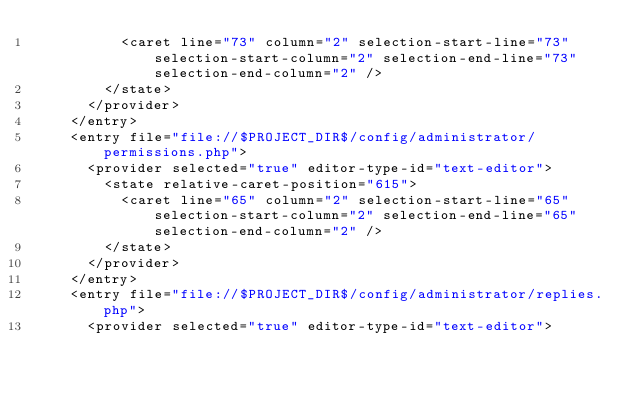Convert code to text. <code><loc_0><loc_0><loc_500><loc_500><_XML_>          <caret line="73" column="2" selection-start-line="73" selection-start-column="2" selection-end-line="73" selection-end-column="2" />
        </state>
      </provider>
    </entry>
    <entry file="file://$PROJECT_DIR$/config/administrator/permissions.php">
      <provider selected="true" editor-type-id="text-editor">
        <state relative-caret-position="615">
          <caret line="65" column="2" selection-start-line="65" selection-start-column="2" selection-end-line="65" selection-end-column="2" />
        </state>
      </provider>
    </entry>
    <entry file="file://$PROJECT_DIR$/config/administrator/replies.php">
      <provider selected="true" editor-type-id="text-editor"></code> 